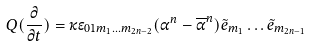<formula> <loc_0><loc_0><loc_500><loc_500>Q ( \frac { \partial } { \partial t } ) = \kappa \epsilon _ { 0 1 m _ { 1 } \dots m _ { 2 n - 2 } } ( \alpha ^ { n } - \overline { \alpha } ^ { n } ) \tilde { e } _ { m _ { 1 } } \dots \tilde { e } _ { m _ { 2 n - 1 } }</formula> 